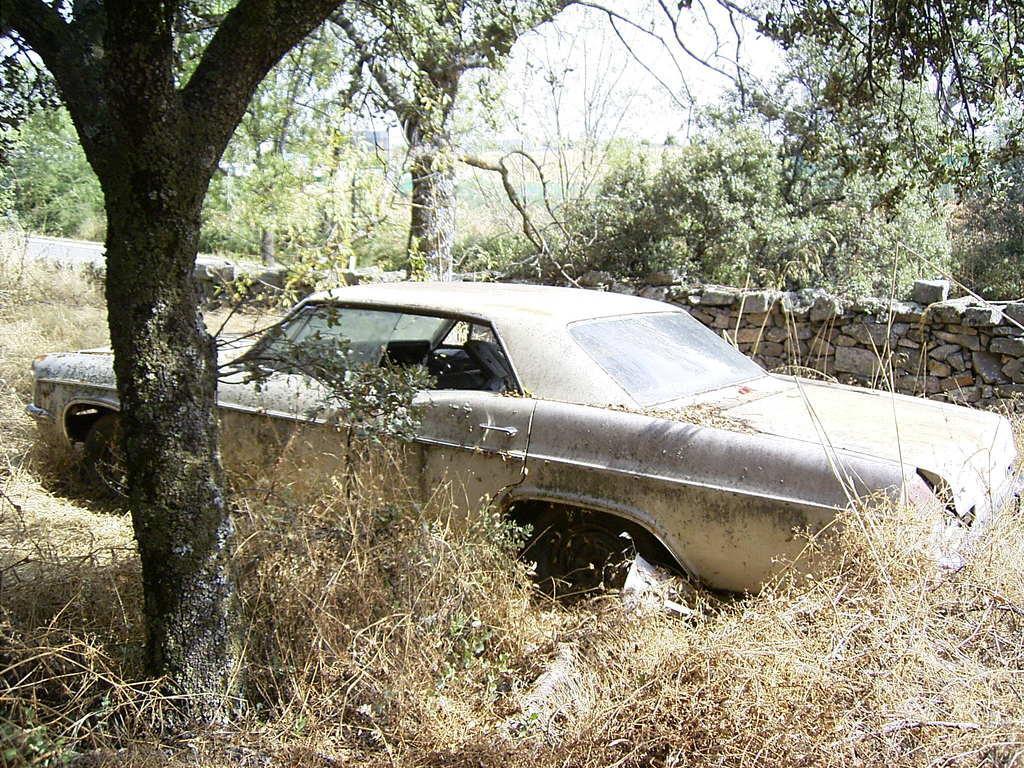In one or two sentences, can you explain what this image depicts? In this picture there is a old unused car and there is a tree beside it and there is a rock wall in the right corner and there are trees in the background. 